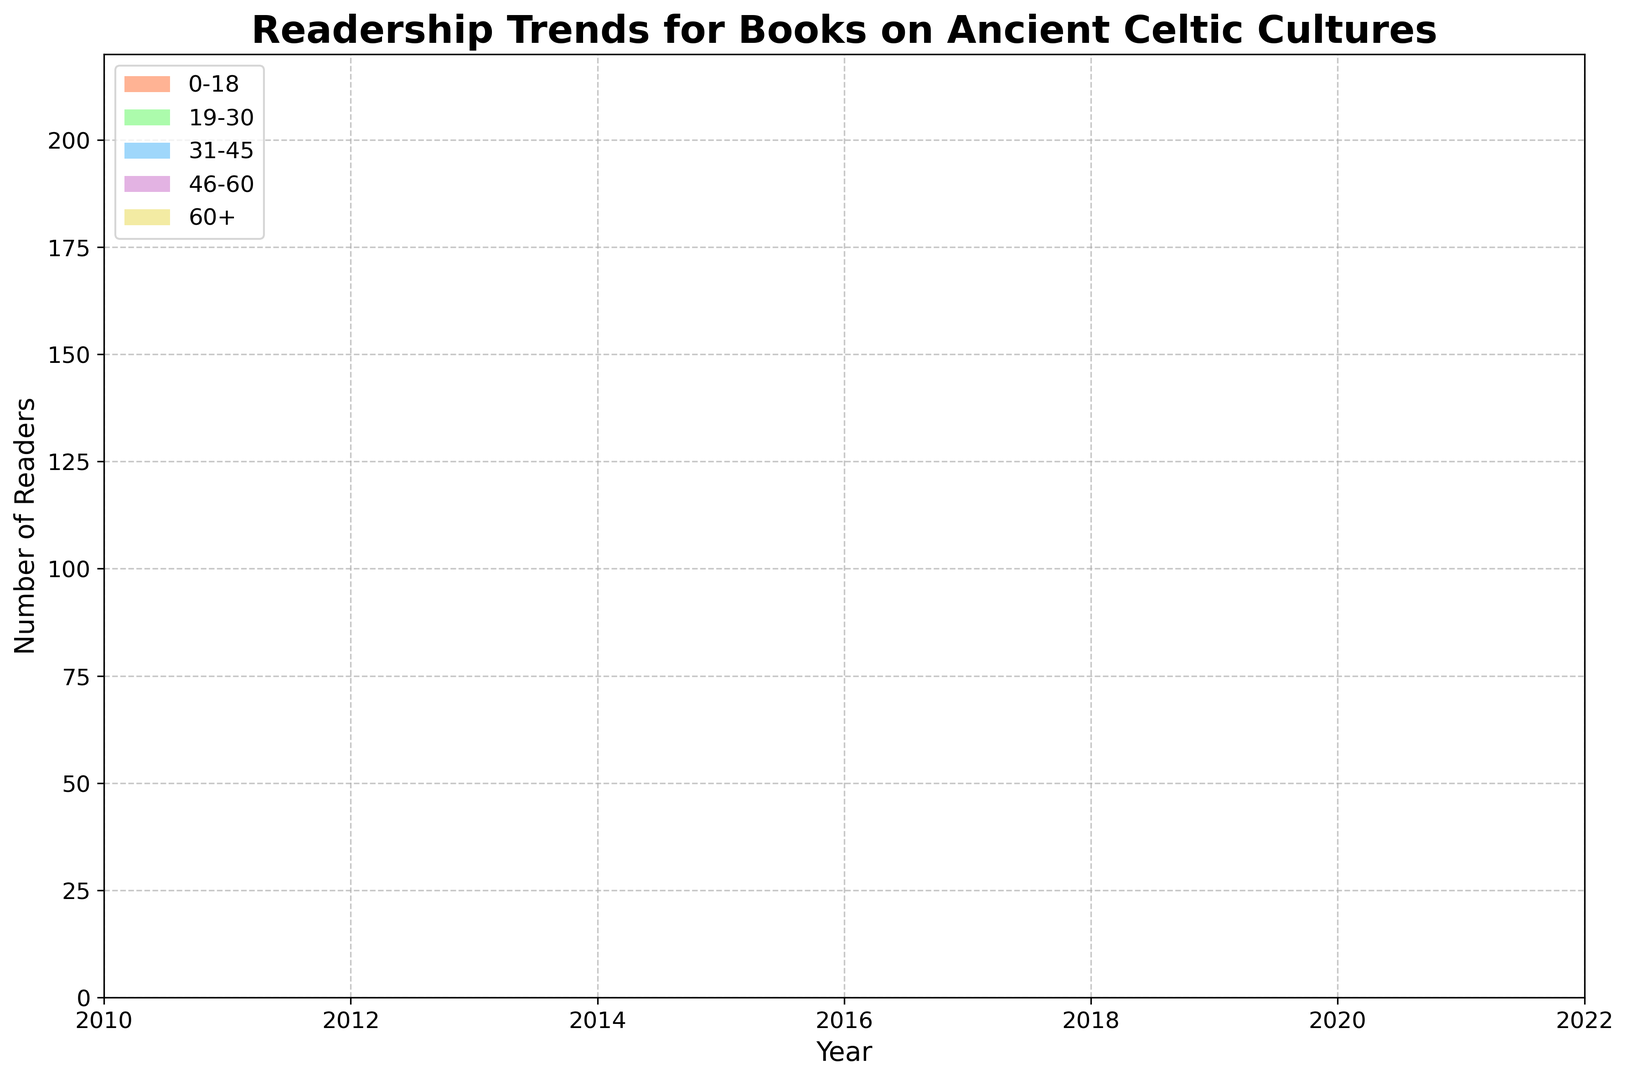What was the total number of readers across all age groups in 2022? First, sum the number of readers in each age group for 2022: 20 + 35 + 42 + 51 + 38 = 186
Answer: 186 Which age group showed the highest increase in readership from 2010 to 2022? Calculate the increase for each age group by subtracting the 2010 value from the 2022 value: 0-18 (20-5=15), 19-30 (35-12=23), 31-45 (42-18=24), 46-60 (51-25=26), 60+ (38-15=23). The 46-60 age group has the highest increase (26).
Answer: 46-60 In which year did the 0-18 age group surpass 10 readers for the first time? Look at the 0-18 age group data over the years and identify the first year it exceeds 10 readers. In 2014, the value is 10 and in 2015, it is 11. Therefore, it surpassed 10 readers in 2015.
Answer: 2015 By how much did the total readership change between 2010 and 2022? Find the total readership for 2010 by summing the values: 5 + 12 + 18 + 25 + 15 = 75. Do the same for 2022: 20 + 35 + 42 + 51 + 38 = 186. The total change is 186 - 75 = 111.
Answer: 111 Which age group consistently shows an increasing trend throughout the years 2010 to 2022? Inspect the trends for all age groups over the years. Each age group shows an increasing number of readers, but the 46-60 age group continuously increases every year without any dips.
Answer: 46-60 How many total readers were there in 2013, and what is the overall trend in readership from 2010 to 2013? Sum the number of readers for 2013 across all age groups: 8 + 17 + 24 + 32 + 20 = 101. To determine the overall trend, observe the total readership trends from 2010 (75), 2011 (85), 2012 (92), and 2013 (101), showing a positive trend.
Answer: 101, positive trend Which age group had the smallest number of readers in 2016, and what was that number? Refer to the 2016 data and find the smallest value: 0-18 (12), 19-30 (23), 31-45 (30), 46-60 (39), 60+ (26). The smallest number is 12, which corresponds to the 0-18 age group.
Answer: 0-18, 12 Between which consecutive years did the total readership see the most significant absolute increase? Calculate the total readership for each year and find the differences: 2010-2011 (85-75=10), 2011-2012 (92-85=7), 2012-2013 (101-92=9), and so on. The most significant increase is between 2021 and 2022: 186 - 177 = 9.
Answer: 2021-2022, 9 